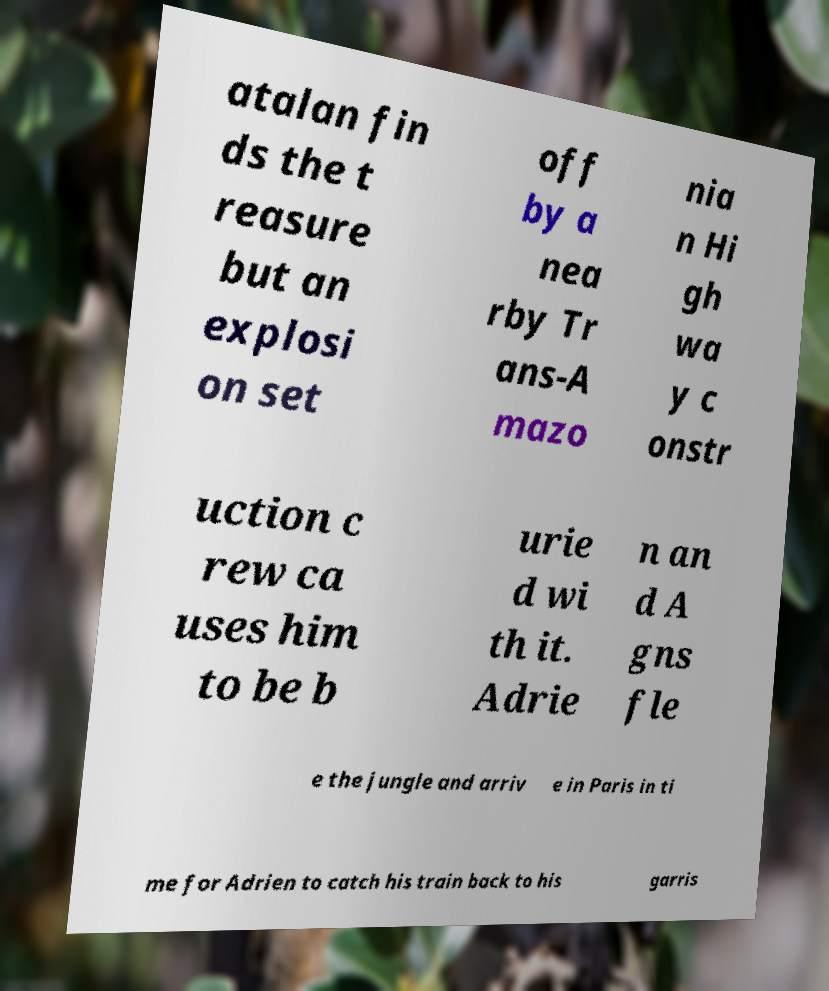What messages or text are displayed in this image? I need them in a readable, typed format. atalan fin ds the t reasure but an explosi on set off by a nea rby Tr ans-A mazo nia n Hi gh wa y c onstr uction c rew ca uses him to be b urie d wi th it. Adrie n an d A gns fle e the jungle and arriv e in Paris in ti me for Adrien to catch his train back to his garris 